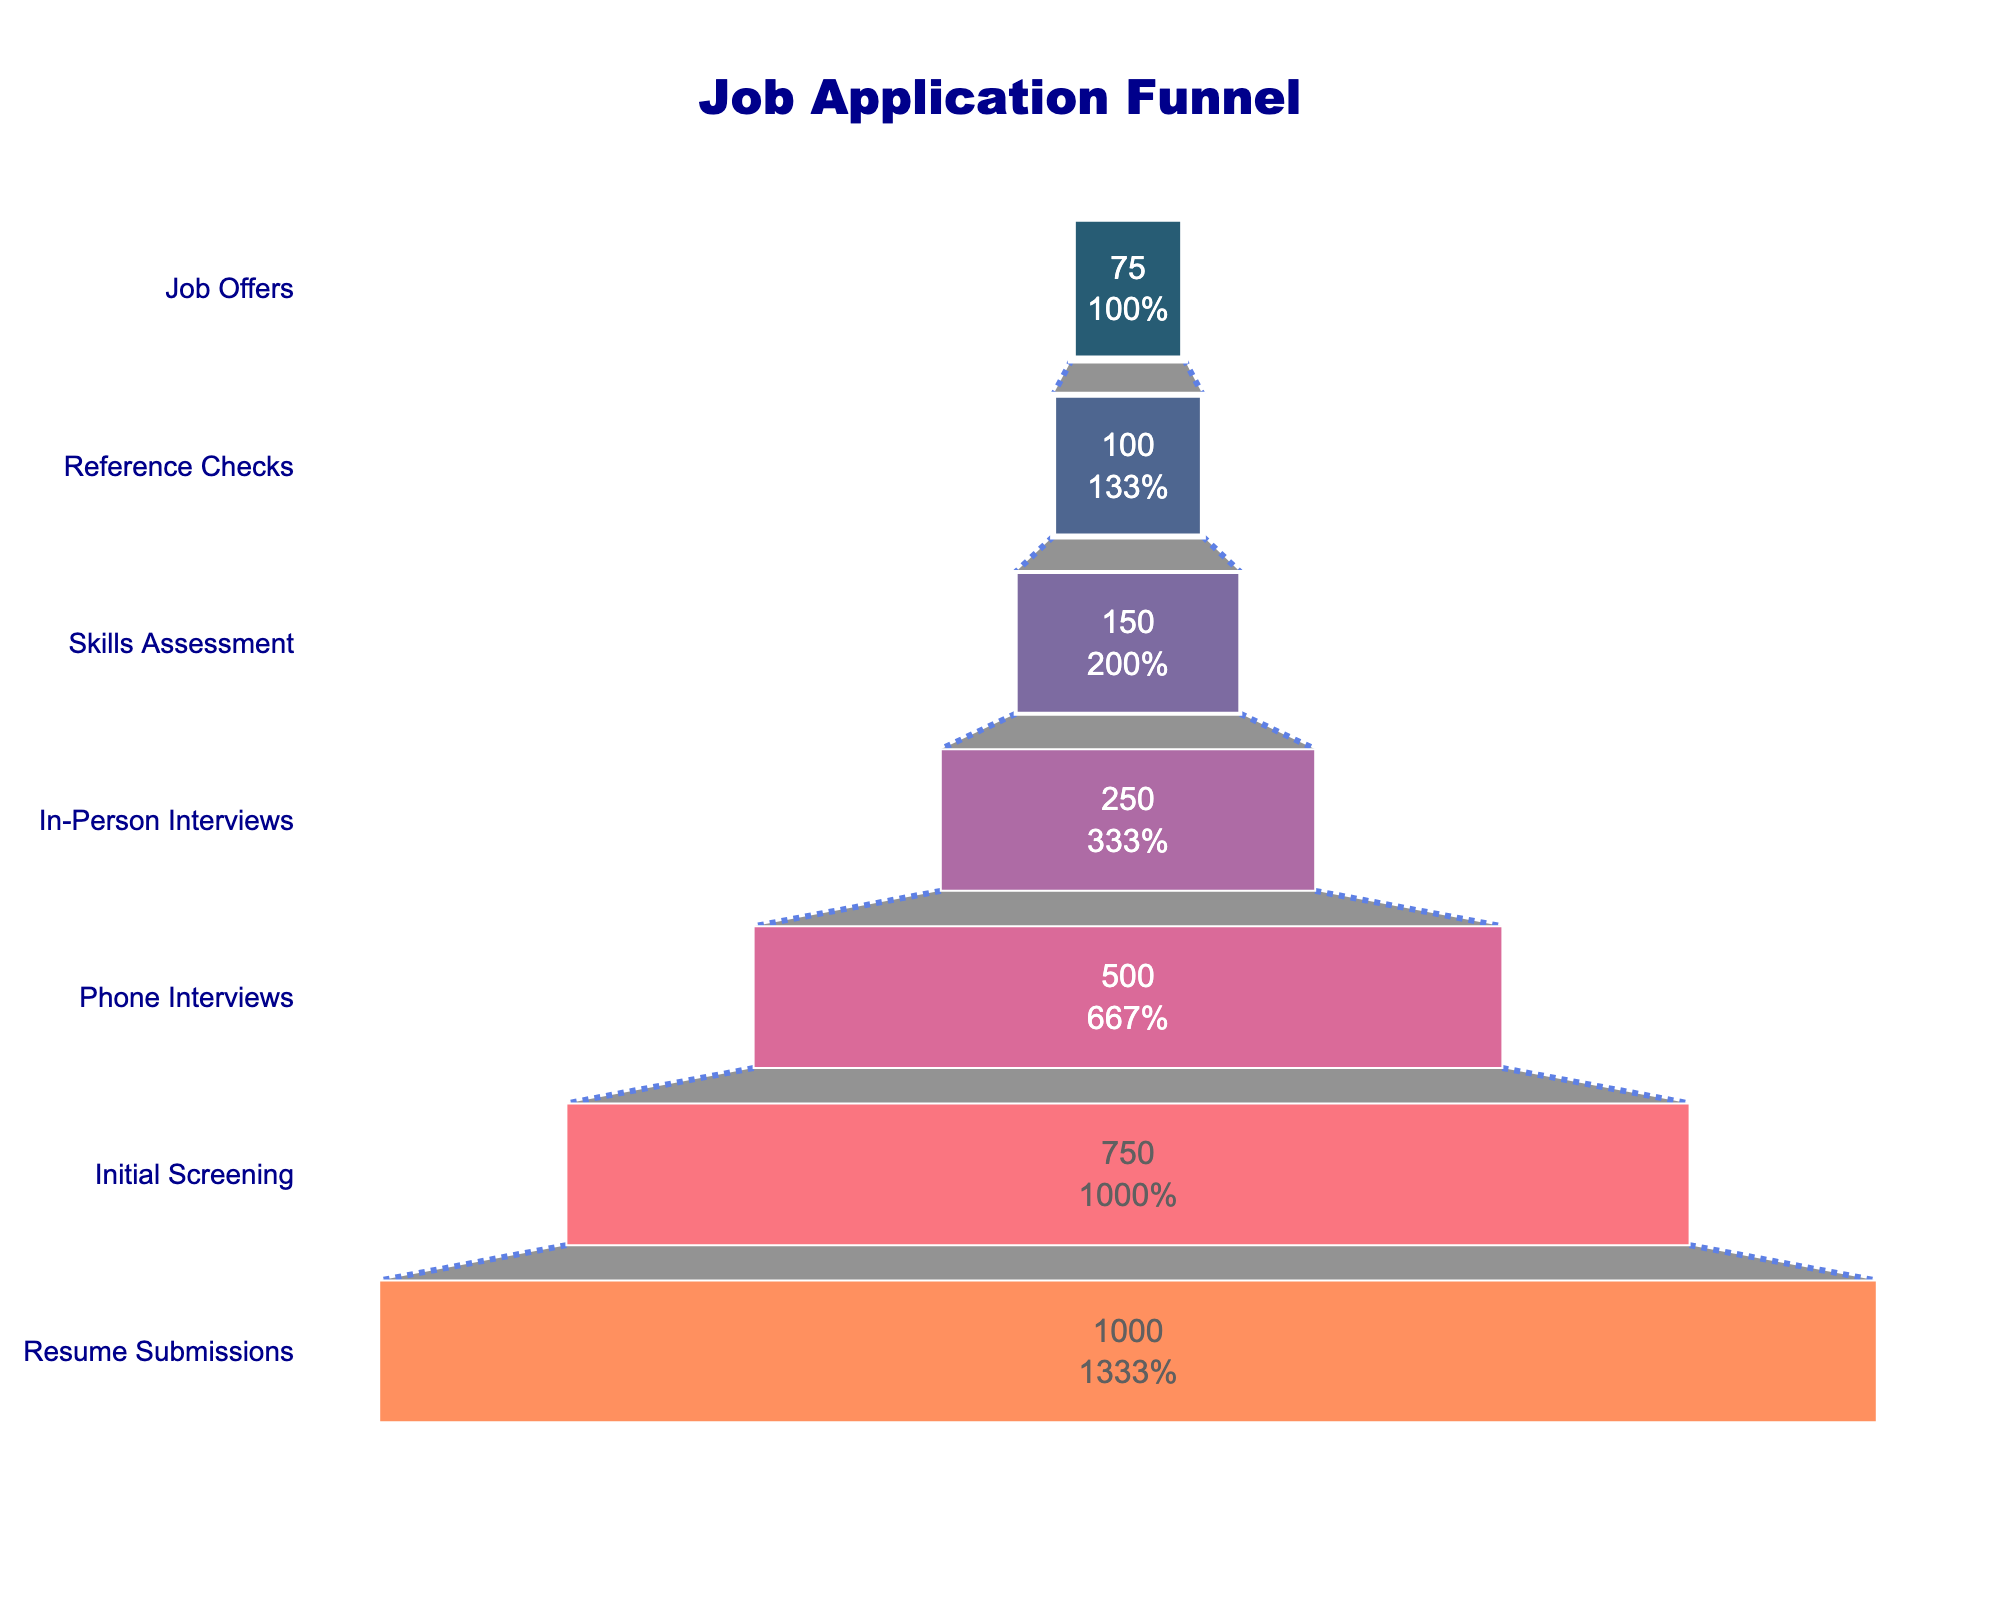What is the title of the funnel chart? The title is located at the top center of the chart in a larger and bold font. It provides a clear overview of what the chart represents.
Answer: Job Application Funnel What percentage of initial applicants progressed to the Initial Screening stage? Look for the percentage labeled inside the bar for the 'Initial Screening' stage.
Answer: 75% How many applicants were left at the Skills Assessment stage? Check the value inside the bar corresponding to the 'Skills Assessment' stage.
Answer: 150 What is the difference in the number of applicants between the In-Person Interviews and Reference Checks stages? Subtract the number of applicants at the Reference Checks stage from the number at the In-Person Interviews stage: 250 - 100.
Answer: 150 Which stage has the highest drop-off rate in terms of applicants? Calculate the drop-off rates between stages and identify the stage with the maximum difference. The largest drop-off appears between 'In-Person Interviews' to 'Skills Assessment': 250 - 150 = 100.
Answer: In-Person Interviews to Skills Assessment How does the number of applicants in the Phone Interviews stage compare to the Reference Checks stage? Compare the values inside the bars for the Phone Interviews and Reference Checks stages, 500 vs. 100.
Answer: Phone Interviews have 400 more applicants What is the ratio of applicants who received Job Offers to those who completed the Initial Screening? Divide the number of Job Offers by the number in the Initial Screening stage: 75 / 750.
Answer: 1:10 By how much does the number of applicants reduce from Resume Submissions to Job Offers? Subtract the number of Job Offers from the number of Resume Submissions: 1000 - 75.
Answer: 925 What color is used for the highest (resume submissions) segment of the funnel? Identify the color of the top-most segment.
Answer: Dark blue How many applicants progressed from the Phone Interviews stage to the In-Person Interviews stage? Subtract the number at the In-Person Interviews stage from the number at the Phone Interviews stage: 500 - 250.
Answer: 250 